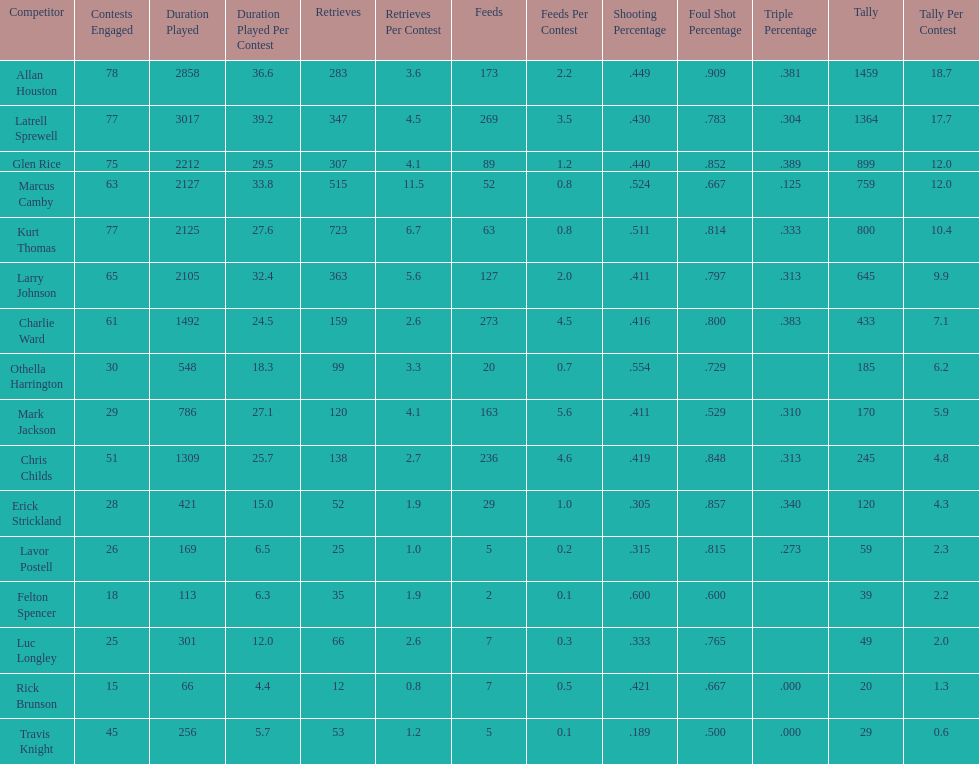How many more games did allan houston play than mark jackson? 49. 